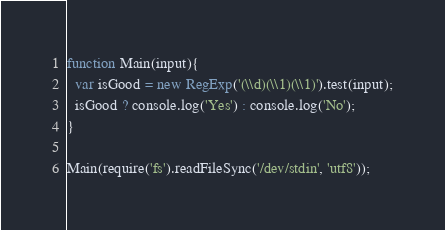<code> <loc_0><loc_0><loc_500><loc_500><_JavaScript_>function Main(input){
  var isGood = new RegExp('(\\d)(\\1)(\\1)').test(input);
  isGood ? console.log('Yes') : console.log('No');
}

Main(require('fs').readFileSync('/dev/stdin', 'utf8'));</code> 